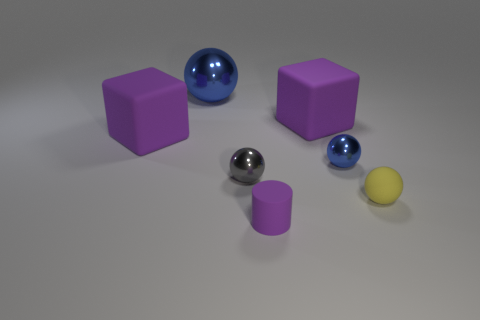Add 1 blue metallic balls. How many objects exist? 8 Subtract all rubber balls. How many balls are left? 3 Subtract 1 cylinders. How many cylinders are left? 0 Subtract all spheres. How many objects are left? 3 Subtract all yellow balls. Subtract all red blocks. How many balls are left? 3 Subtract all yellow cylinders. How many green spheres are left? 0 Subtract all tiny brown metallic cylinders. Subtract all large blocks. How many objects are left? 5 Add 7 blue metal balls. How many blue metal balls are left? 9 Add 5 big cyan rubber cylinders. How many big cyan rubber cylinders exist? 5 Subtract all blue spheres. How many spheres are left? 2 